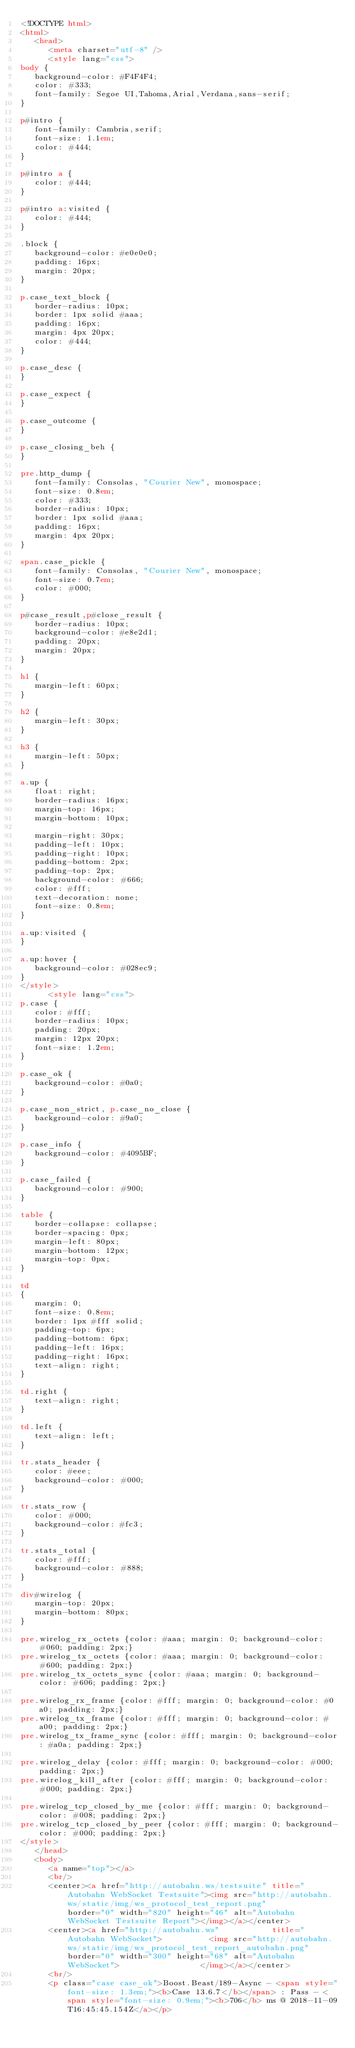<code> <loc_0><loc_0><loc_500><loc_500><_HTML_><!DOCTYPE html>
<html>
   <head>
      <meta charset="utf-8" />
      <style lang="css">
body {
   background-color: #F4F4F4;
   color: #333;
   font-family: Segoe UI,Tahoma,Arial,Verdana,sans-serif;
}

p#intro {
   font-family: Cambria,serif;
   font-size: 1.1em;
   color: #444;
}

p#intro a {
   color: #444;
}

p#intro a:visited {
   color: #444;
}

.block {
   background-color: #e0e0e0;
   padding: 16px;
   margin: 20px;
}

p.case_text_block {
   border-radius: 10px;
   border: 1px solid #aaa;
   padding: 16px;
   margin: 4px 20px;
   color: #444;
}

p.case_desc {
}

p.case_expect {
}

p.case_outcome {
}

p.case_closing_beh {
}

pre.http_dump {
   font-family: Consolas, "Courier New", monospace;
   font-size: 0.8em;
   color: #333;
   border-radius: 10px;
   border: 1px solid #aaa;
   padding: 16px;
   margin: 4px 20px;
}

span.case_pickle {
   font-family: Consolas, "Courier New", monospace;
   font-size: 0.7em;
   color: #000;
}

p#case_result,p#close_result {
   border-radius: 10px;
   background-color: #e8e2d1;
   padding: 20px;
   margin: 20px;
}

h1 {
   margin-left: 60px;
}

h2 {
   margin-left: 30px;
}

h3 {
   margin-left: 50px;
}

a.up {
   float: right;
   border-radius: 16px;
   margin-top: 16px;
   margin-bottom: 10px;

   margin-right: 30px;
   padding-left: 10px;
   padding-right: 10px;
   padding-bottom: 2px;
   padding-top: 2px;
   background-color: #666;
   color: #fff;
   text-decoration: none;
   font-size: 0.8em;
}

a.up:visited {
}

a.up:hover {
   background-color: #028ec9;
}
</style>
      <style lang="css">
p.case {
   color: #fff;
   border-radius: 10px;
   padding: 20px;
   margin: 12px 20px;
   font-size: 1.2em;
}

p.case_ok {
   background-color: #0a0;
}

p.case_non_strict, p.case_no_close {
   background-color: #9a0;
}

p.case_info {
   background-color: #4095BF;
}

p.case_failed {
   background-color: #900;
}

table {
   border-collapse: collapse;
   border-spacing: 0px;
   margin-left: 80px;
   margin-bottom: 12px;
   margin-top: 0px;
}

td
{
   margin: 0;
   font-size: 0.8em;
   border: 1px #fff solid;
   padding-top: 6px;
   padding-bottom: 6px;
   padding-left: 16px;
   padding-right: 16px;
   text-align: right;
}

td.right {
   text-align: right;
}

td.left {
   text-align: left;
}

tr.stats_header {
   color: #eee;
   background-color: #000;
}

tr.stats_row {
   color: #000;
   background-color: #fc3;
}

tr.stats_total {
   color: #fff;
   background-color: #888;
}

div#wirelog {
   margin-top: 20px;
   margin-bottom: 80px;
}

pre.wirelog_rx_octets {color: #aaa; margin: 0; background-color: #060; padding: 2px;}
pre.wirelog_tx_octets {color: #aaa; margin: 0; background-color: #600; padding: 2px;}
pre.wirelog_tx_octets_sync {color: #aaa; margin: 0; background-color: #606; padding: 2px;}

pre.wirelog_rx_frame {color: #fff; margin: 0; background-color: #0a0; padding: 2px;}
pre.wirelog_tx_frame {color: #fff; margin: 0; background-color: #a00; padding: 2px;}
pre.wirelog_tx_frame_sync {color: #fff; margin: 0; background-color: #a0a; padding: 2px;}

pre.wirelog_delay {color: #fff; margin: 0; background-color: #000; padding: 2px;}
pre.wirelog_kill_after {color: #fff; margin: 0; background-color: #000; padding: 2px;}

pre.wirelog_tcp_closed_by_me {color: #fff; margin: 0; background-color: #008; padding: 2px;}
pre.wirelog_tcp_closed_by_peer {color: #fff; margin: 0; background-color: #000; padding: 2px;}
</style>
   </head>
   <body>
      <a name="top"></a>
      <br/>
      <center><a href="http://autobahn.ws/testsuite" title="Autobahn WebSocket Testsuite"><img src="http://autobahn.ws/static/img/ws_protocol_test_report.png"          border="0" width="820" height="46" alt="Autobahn WebSocket Testsuite Report"></img></a></center>
      <center><a href="http://autobahn.ws"           title="Autobahn WebSocket">          <img src="http://autobahn.ws/static/img/ws_protocol_test_report_autobahn.png" border="0" width="300" height="68" alt="Autobahn WebSocket">                 </img></a></center>
      <br/>
      <p class="case case_ok">Boost.Beast/189-Async - <span style="font-size: 1.3em;"><b>Case 13.6.7</b></span> : Pass - <span style="font-size: 0.9em;"><b>706</b> ms @ 2018-11-09T16:45:45.154Z</a></p></code> 